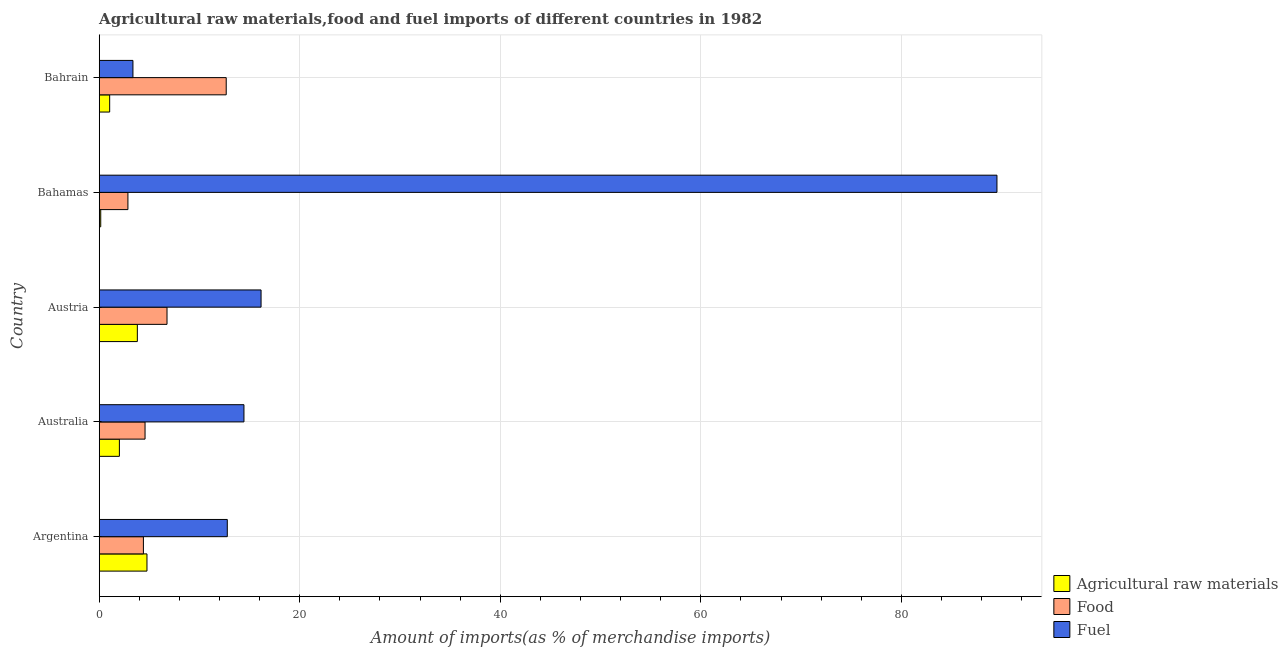How many groups of bars are there?
Ensure brevity in your answer.  5. How many bars are there on the 2nd tick from the top?
Keep it short and to the point. 3. What is the label of the 2nd group of bars from the top?
Your answer should be very brief. Bahamas. In how many cases, is the number of bars for a given country not equal to the number of legend labels?
Make the answer very short. 0. What is the percentage of fuel imports in Argentina?
Your response must be concise. 12.77. Across all countries, what is the maximum percentage of fuel imports?
Offer a terse response. 89.53. Across all countries, what is the minimum percentage of fuel imports?
Give a very brief answer. 3.36. In which country was the percentage of food imports minimum?
Offer a very short reply. Bahamas. What is the total percentage of raw materials imports in the graph?
Your answer should be compact. 11.77. What is the difference between the percentage of fuel imports in Austria and that in Bahamas?
Provide a short and direct response. -73.39. What is the difference between the percentage of raw materials imports in Australia and the percentage of fuel imports in Bahrain?
Provide a short and direct response. -1.35. What is the average percentage of food imports per country?
Offer a terse response. 6.25. What is the difference between the percentage of fuel imports and percentage of raw materials imports in Argentina?
Your answer should be compact. 8.01. What is the ratio of the percentage of food imports in Australia to that in Bahamas?
Offer a terse response. 1.6. Is the percentage of food imports in Australia less than that in Austria?
Your answer should be very brief. Yes. What is the difference between the highest and the second highest percentage of fuel imports?
Offer a very short reply. 73.39. What is the difference between the highest and the lowest percentage of fuel imports?
Your response must be concise. 86.17. In how many countries, is the percentage of food imports greater than the average percentage of food imports taken over all countries?
Give a very brief answer. 2. Is the sum of the percentage of food imports in Argentina and Austria greater than the maximum percentage of raw materials imports across all countries?
Offer a terse response. Yes. What does the 3rd bar from the top in Argentina represents?
Provide a short and direct response. Agricultural raw materials. What does the 3rd bar from the bottom in Austria represents?
Your answer should be very brief. Fuel. Where does the legend appear in the graph?
Ensure brevity in your answer.  Bottom right. What is the title of the graph?
Make the answer very short. Agricultural raw materials,food and fuel imports of different countries in 1982. What is the label or title of the X-axis?
Offer a terse response. Amount of imports(as % of merchandise imports). What is the Amount of imports(as % of merchandise imports) of Agricultural raw materials in Argentina?
Offer a terse response. 4.76. What is the Amount of imports(as % of merchandise imports) in Food in Argentina?
Keep it short and to the point. 4.41. What is the Amount of imports(as % of merchandise imports) of Fuel in Argentina?
Give a very brief answer. 12.77. What is the Amount of imports(as % of merchandise imports) of Agricultural raw materials in Australia?
Your response must be concise. 2.01. What is the Amount of imports(as % of merchandise imports) in Food in Australia?
Provide a short and direct response. 4.57. What is the Amount of imports(as % of merchandise imports) in Fuel in Australia?
Provide a short and direct response. 14.43. What is the Amount of imports(as % of merchandise imports) of Agricultural raw materials in Austria?
Offer a very short reply. 3.8. What is the Amount of imports(as % of merchandise imports) of Food in Austria?
Provide a succinct answer. 6.76. What is the Amount of imports(as % of merchandise imports) of Fuel in Austria?
Offer a very short reply. 16.14. What is the Amount of imports(as % of merchandise imports) in Agricultural raw materials in Bahamas?
Provide a succinct answer. 0.15. What is the Amount of imports(as % of merchandise imports) in Food in Bahamas?
Offer a very short reply. 2.86. What is the Amount of imports(as % of merchandise imports) in Fuel in Bahamas?
Offer a very short reply. 89.53. What is the Amount of imports(as % of merchandise imports) of Agricultural raw materials in Bahrain?
Ensure brevity in your answer.  1.04. What is the Amount of imports(as % of merchandise imports) in Food in Bahrain?
Your answer should be compact. 12.67. What is the Amount of imports(as % of merchandise imports) of Fuel in Bahrain?
Offer a very short reply. 3.36. Across all countries, what is the maximum Amount of imports(as % of merchandise imports) in Agricultural raw materials?
Ensure brevity in your answer.  4.76. Across all countries, what is the maximum Amount of imports(as % of merchandise imports) in Food?
Your answer should be very brief. 12.67. Across all countries, what is the maximum Amount of imports(as % of merchandise imports) in Fuel?
Your response must be concise. 89.53. Across all countries, what is the minimum Amount of imports(as % of merchandise imports) of Agricultural raw materials?
Ensure brevity in your answer.  0.15. Across all countries, what is the minimum Amount of imports(as % of merchandise imports) in Food?
Make the answer very short. 2.86. Across all countries, what is the minimum Amount of imports(as % of merchandise imports) of Fuel?
Ensure brevity in your answer.  3.36. What is the total Amount of imports(as % of merchandise imports) of Agricultural raw materials in the graph?
Provide a short and direct response. 11.77. What is the total Amount of imports(as % of merchandise imports) of Food in the graph?
Provide a succinct answer. 31.27. What is the total Amount of imports(as % of merchandise imports) of Fuel in the graph?
Your answer should be compact. 136.25. What is the difference between the Amount of imports(as % of merchandise imports) of Agricultural raw materials in Argentina and that in Australia?
Keep it short and to the point. 2.75. What is the difference between the Amount of imports(as % of merchandise imports) in Food in Argentina and that in Australia?
Offer a terse response. -0.16. What is the difference between the Amount of imports(as % of merchandise imports) of Fuel in Argentina and that in Australia?
Keep it short and to the point. -1.66. What is the difference between the Amount of imports(as % of merchandise imports) of Agricultural raw materials in Argentina and that in Austria?
Offer a very short reply. 0.96. What is the difference between the Amount of imports(as % of merchandise imports) in Food in Argentina and that in Austria?
Offer a very short reply. -2.35. What is the difference between the Amount of imports(as % of merchandise imports) of Fuel in Argentina and that in Austria?
Provide a succinct answer. -3.37. What is the difference between the Amount of imports(as % of merchandise imports) in Agricultural raw materials in Argentina and that in Bahamas?
Your answer should be very brief. 4.61. What is the difference between the Amount of imports(as % of merchandise imports) of Food in Argentina and that in Bahamas?
Keep it short and to the point. 1.54. What is the difference between the Amount of imports(as % of merchandise imports) of Fuel in Argentina and that in Bahamas?
Provide a succinct answer. -76.76. What is the difference between the Amount of imports(as % of merchandise imports) of Agricultural raw materials in Argentina and that in Bahrain?
Your response must be concise. 3.72. What is the difference between the Amount of imports(as % of merchandise imports) in Food in Argentina and that in Bahrain?
Keep it short and to the point. -8.26. What is the difference between the Amount of imports(as % of merchandise imports) in Fuel in Argentina and that in Bahrain?
Your answer should be very brief. 9.41. What is the difference between the Amount of imports(as % of merchandise imports) of Agricultural raw materials in Australia and that in Austria?
Make the answer very short. -1.79. What is the difference between the Amount of imports(as % of merchandise imports) of Food in Australia and that in Austria?
Offer a terse response. -2.19. What is the difference between the Amount of imports(as % of merchandise imports) in Fuel in Australia and that in Austria?
Your answer should be compact. -1.71. What is the difference between the Amount of imports(as % of merchandise imports) of Agricultural raw materials in Australia and that in Bahamas?
Make the answer very short. 1.86. What is the difference between the Amount of imports(as % of merchandise imports) of Food in Australia and that in Bahamas?
Give a very brief answer. 1.71. What is the difference between the Amount of imports(as % of merchandise imports) of Fuel in Australia and that in Bahamas?
Your answer should be very brief. -75.1. What is the difference between the Amount of imports(as % of merchandise imports) in Agricultural raw materials in Australia and that in Bahrain?
Offer a very short reply. 0.97. What is the difference between the Amount of imports(as % of merchandise imports) of Food in Australia and that in Bahrain?
Provide a succinct answer. -8.1. What is the difference between the Amount of imports(as % of merchandise imports) in Fuel in Australia and that in Bahrain?
Ensure brevity in your answer.  11.07. What is the difference between the Amount of imports(as % of merchandise imports) in Agricultural raw materials in Austria and that in Bahamas?
Keep it short and to the point. 3.65. What is the difference between the Amount of imports(as % of merchandise imports) of Food in Austria and that in Bahamas?
Your answer should be very brief. 3.9. What is the difference between the Amount of imports(as % of merchandise imports) of Fuel in Austria and that in Bahamas?
Keep it short and to the point. -73.39. What is the difference between the Amount of imports(as % of merchandise imports) in Agricultural raw materials in Austria and that in Bahrain?
Offer a very short reply. 2.76. What is the difference between the Amount of imports(as % of merchandise imports) of Food in Austria and that in Bahrain?
Keep it short and to the point. -5.91. What is the difference between the Amount of imports(as % of merchandise imports) of Fuel in Austria and that in Bahrain?
Give a very brief answer. 12.78. What is the difference between the Amount of imports(as % of merchandise imports) of Agricultural raw materials in Bahamas and that in Bahrain?
Offer a terse response. -0.89. What is the difference between the Amount of imports(as % of merchandise imports) of Food in Bahamas and that in Bahrain?
Give a very brief answer. -9.8. What is the difference between the Amount of imports(as % of merchandise imports) of Fuel in Bahamas and that in Bahrain?
Provide a succinct answer. 86.17. What is the difference between the Amount of imports(as % of merchandise imports) in Agricultural raw materials in Argentina and the Amount of imports(as % of merchandise imports) in Food in Australia?
Offer a terse response. 0.19. What is the difference between the Amount of imports(as % of merchandise imports) in Agricultural raw materials in Argentina and the Amount of imports(as % of merchandise imports) in Fuel in Australia?
Your answer should be very brief. -9.67. What is the difference between the Amount of imports(as % of merchandise imports) in Food in Argentina and the Amount of imports(as % of merchandise imports) in Fuel in Australia?
Make the answer very short. -10.03. What is the difference between the Amount of imports(as % of merchandise imports) of Agricultural raw materials in Argentina and the Amount of imports(as % of merchandise imports) of Food in Austria?
Provide a short and direct response. -2. What is the difference between the Amount of imports(as % of merchandise imports) in Agricultural raw materials in Argentina and the Amount of imports(as % of merchandise imports) in Fuel in Austria?
Offer a very short reply. -11.38. What is the difference between the Amount of imports(as % of merchandise imports) in Food in Argentina and the Amount of imports(as % of merchandise imports) in Fuel in Austria?
Your answer should be compact. -11.73. What is the difference between the Amount of imports(as % of merchandise imports) in Agricultural raw materials in Argentina and the Amount of imports(as % of merchandise imports) in Food in Bahamas?
Provide a succinct answer. 1.9. What is the difference between the Amount of imports(as % of merchandise imports) in Agricultural raw materials in Argentina and the Amount of imports(as % of merchandise imports) in Fuel in Bahamas?
Give a very brief answer. -84.77. What is the difference between the Amount of imports(as % of merchandise imports) in Food in Argentina and the Amount of imports(as % of merchandise imports) in Fuel in Bahamas?
Keep it short and to the point. -85.13. What is the difference between the Amount of imports(as % of merchandise imports) of Agricultural raw materials in Argentina and the Amount of imports(as % of merchandise imports) of Food in Bahrain?
Give a very brief answer. -7.9. What is the difference between the Amount of imports(as % of merchandise imports) of Agricultural raw materials in Argentina and the Amount of imports(as % of merchandise imports) of Fuel in Bahrain?
Make the answer very short. 1.4. What is the difference between the Amount of imports(as % of merchandise imports) in Food in Argentina and the Amount of imports(as % of merchandise imports) in Fuel in Bahrain?
Provide a succinct answer. 1.04. What is the difference between the Amount of imports(as % of merchandise imports) of Agricultural raw materials in Australia and the Amount of imports(as % of merchandise imports) of Food in Austria?
Make the answer very short. -4.75. What is the difference between the Amount of imports(as % of merchandise imports) of Agricultural raw materials in Australia and the Amount of imports(as % of merchandise imports) of Fuel in Austria?
Offer a very short reply. -14.13. What is the difference between the Amount of imports(as % of merchandise imports) in Food in Australia and the Amount of imports(as % of merchandise imports) in Fuel in Austria?
Ensure brevity in your answer.  -11.57. What is the difference between the Amount of imports(as % of merchandise imports) in Agricultural raw materials in Australia and the Amount of imports(as % of merchandise imports) in Food in Bahamas?
Make the answer very short. -0.85. What is the difference between the Amount of imports(as % of merchandise imports) in Agricultural raw materials in Australia and the Amount of imports(as % of merchandise imports) in Fuel in Bahamas?
Keep it short and to the point. -87.52. What is the difference between the Amount of imports(as % of merchandise imports) in Food in Australia and the Amount of imports(as % of merchandise imports) in Fuel in Bahamas?
Make the answer very short. -84.96. What is the difference between the Amount of imports(as % of merchandise imports) of Agricultural raw materials in Australia and the Amount of imports(as % of merchandise imports) of Food in Bahrain?
Offer a very short reply. -10.65. What is the difference between the Amount of imports(as % of merchandise imports) of Agricultural raw materials in Australia and the Amount of imports(as % of merchandise imports) of Fuel in Bahrain?
Ensure brevity in your answer.  -1.35. What is the difference between the Amount of imports(as % of merchandise imports) of Food in Australia and the Amount of imports(as % of merchandise imports) of Fuel in Bahrain?
Give a very brief answer. 1.21. What is the difference between the Amount of imports(as % of merchandise imports) in Agricultural raw materials in Austria and the Amount of imports(as % of merchandise imports) in Food in Bahamas?
Give a very brief answer. 0.94. What is the difference between the Amount of imports(as % of merchandise imports) in Agricultural raw materials in Austria and the Amount of imports(as % of merchandise imports) in Fuel in Bahamas?
Offer a terse response. -85.73. What is the difference between the Amount of imports(as % of merchandise imports) of Food in Austria and the Amount of imports(as % of merchandise imports) of Fuel in Bahamas?
Give a very brief answer. -82.77. What is the difference between the Amount of imports(as % of merchandise imports) in Agricultural raw materials in Austria and the Amount of imports(as % of merchandise imports) in Food in Bahrain?
Offer a very short reply. -8.86. What is the difference between the Amount of imports(as % of merchandise imports) in Agricultural raw materials in Austria and the Amount of imports(as % of merchandise imports) in Fuel in Bahrain?
Offer a very short reply. 0.44. What is the difference between the Amount of imports(as % of merchandise imports) in Food in Austria and the Amount of imports(as % of merchandise imports) in Fuel in Bahrain?
Make the answer very short. 3.4. What is the difference between the Amount of imports(as % of merchandise imports) of Agricultural raw materials in Bahamas and the Amount of imports(as % of merchandise imports) of Food in Bahrain?
Your answer should be compact. -12.52. What is the difference between the Amount of imports(as % of merchandise imports) in Agricultural raw materials in Bahamas and the Amount of imports(as % of merchandise imports) in Fuel in Bahrain?
Keep it short and to the point. -3.21. What is the difference between the Amount of imports(as % of merchandise imports) of Food in Bahamas and the Amount of imports(as % of merchandise imports) of Fuel in Bahrain?
Offer a terse response. -0.5. What is the average Amount of imports(as % of merchandise imports) in Agricultural raw materials per country?
Keep it short and to the point. 2.35. What is the average Amount of imports(as % of merchandise imports) in Food per country?
Ensure brevity in your answer.  6.25. What is the average Amount of imports(as % of merchandise imports) in Fuel per country?
Give a very brief answer. 27.25. What is the difference between the Amount of imports(as % of merchandise imports) in Agricultural raw materials and Amount of imports(as % of merchandise imports) in Food in Argentina?
Provide a succinct answer. 0.36. What is the difference between the Amount of imports(as % of merchandise imports) in Agricultural raw materials and Amount of imports(as % of merchandise imports) in Fuel in Argentina?
Provide a succinct answer. -8.01. What is the difference between the Amount of imports(as % of merchandise imports) in Food and Amount of imports(as % of merchandise imports) in Fuel in Argentina?
Make the answer very short. -8.37. What is the difference between the Amount of imports(as % of merchandise imports) of Agricultural raw materials and Amount of imports(as % of merchandise imports) of Food in Australia?
Offer a very short reply. -2.56. What is the difference between the Amount of imports(as % of merchandise imports) of Agricultural raw materials and Amount of imports(as % of merchandise imports) of Fuel in Australia?
Provide a short and direct response. -12.42. What is the difference between the Amount of imports(as % of merchandise imports) in Food and Amount of imports(as % of merchandise imports) in Fuel in Australia?
Your answer should be compact. -9.86. What is the difference between the Amount of imports(as % of merchandise imports) in Agricultural raw materials and Amount of imports(as % of merchandise imports) in Food in Austria?
Offer a very short reply. -2.96. What is the difference between the Amount of imports(as % of merchandise imports) in Agricultural raw materials and Amount of imports(as % of merchandise imports) in Fuel in Austria?
Offer a terse response. -12.34. What is the difference between the Amount of imports(as % of merchandise imports) of Food and Amount of imports(as % of merchandise imports) of Fuel in Austria?
Make the answer very short. -9.38. What is the difference between the Amount of imports(as % of merchandise imports) of Agricultural raw materials and Amount of imports(as % of merchandise imports) of Food in Bahamas?
Offer a terse response. -2.71. What is the difference between the Amount of imports(as % of merchandise imports) of Agricultural raw materials and Amount of imports(as % of merchandise imports) of Fuel in Bahamas?
Make the answer very short. -89.38. What is the difference between the Amount of imports(as % of merchandise imports) of Food and Amount of imports(as % of merchandise imports) of Fuel in Bahamas?
Provide a short and direct response. -86.67. What is the difference between the Amount of imports(as % of merchandise imports) in Agricultural raw materials and Amount of imports(as % of merchandise imports) in Food in Bahrain?
Make the answer very short. -11.62. What is the difference between the Amount of imports(as % of merchandise imports) in Agricultural raw materials and Amount of imports(as % of merchandise imports) in Fuel in Bahrain?
Ensure brevity in your answer.  -2.32. What is the difference between the Amount of imports(as % of merchandise imports) in Food and Amount of imports(as % of merchandise imports) in Fuel in Bahrain?
Your answer should be compact. 9.3. What is the ratio of the Amount of imports(as % of merchandise imports) in Agricultural raw materials in Argentina to that in Australia?
Provide a succinct answer. 2.37. What is the ratio of the Amount of imports(as % of merchandise imports) in Food in Argentina to that in Australia?
Your answer should be very brief. 0.96. What is the ratio of the Amount of imports(as % of merchandise imports) of Fuel in Argentina to that in Australia?
Your answer should be compact. 0.89. What is the ratio of the Amount of imports(as % of merchandise imports) in Agricultural raw materials in Argentina to that in Austria?
Ensure brevity in your answer.  1.25. What is the ratio of the Amount of imports(as % of merchandise imports) in Food in Argentina to that in Austria?
Your answer should be compact. 0.65. What is the ratio of the Amount of imports(as % of merchandise imports) in Fuel in Argentina to that in Austria?
Your answer should be very brief. 0.79. What is the ratio of the Amount of imports(as % of merchandise imports) of Agricultural raw materials in Argentina to that in Bahamas?
Give a very brief answer. 31.51. What is the ratio of the Amount of imports(as % of merchandise imports) of Food in Argentina to that in Bahamas?
Your response must be concise. 1.54. What is the ratio of the Amount of imports(as % of merchandise imports) in Fuel in Argentina to that in Bahamas?
Your answer should be very brief. 0.14. What is the ratio of the Amount of imports(as % of merchandise imports) in Agricultural raw materials in Argentina to that in Bahrain?
Provide a succinct answer. 4.57. What is the ratio of the Amount of imports(as % of merchandise imports) of Food in Argentina to that in Bahrain?
Make the answer very short. 0.35. What is the ratio of the Amount of imports(as % of merchandise imports) of Fuel in Argentina to that in Bahrain?
Provide a short and direct response. 3.8. What is the ratio of the Amount of imports(as % of merchandise imports) of Agricultural raw materials in Australia to that in Austria?
Provide a succinct answer. 0.53. What is the ratio of the Amount of imports(as % of merchandise imports) of Food in Australia to that in Austria?
Keep it short and to the point. 0.68. What is the ratio of the Amount of imports(as % of merchandise imports) of Fuel in Australia to that in Austria?
Offer a terse response. 0.89. What is the ratio of the Amount of imports(as % of merchandise imports) in Agricultural raw materials in Australia to that in Bahamas?
Your answer should be compact. 13.31. What is the ratio of the Amount of imports(as % of merchandise imports) of Food in Australia to that in Bahamas?
Offer a terse response. 1.6. What is the ratio of the Amount of imports(as % of merchandise imports) in Fuel in Australia to that in Bahamas?
Provide a succinct answer. 0.16. What is the ratio of the Amount of imports(as % of merchandise imports) of Agricultural raw materials in Australia to that in Bahrain?
Offer a very short reply. 1.93. What is the ratio of the Amount of imports(as % of merchandise imports) of Food in Australia to that in Bahrain?
Give a very brief answer. 0.36. What is the ratio of the Amount of imports(as % of merchandise imports) of Fuel in Australia to that in Bahrain?
Your answer should be compact. 4.29. What is the ratio of the Amount of imports(as % of merchandise imports) of Agricultural raw materials in Austria to that in Bahamas?
Keep it short and to the point. 25.16. What is the ratio of the Amount of imports(as % of merchandise imports) in Food in Austria to that in Bahamas?
Your response must be concise. 2.36. What is the ratio of the Amount of imports(as % of merchandise imports) in Fuel in Austria to that in Bahamas?
Offer a very short reply. 0.18. What is the ratio of the Amount of imports(as % of merchandise imports) in Agricultural raw materials in Austria to that in Bahrain?
Provide a succinct answer. 3.65. What is the ratio of the Amount of imports(as % of merchandise imports) of Food in Austria to that in Bahrain?
Offer a terse response. 0.53. What is the ratio of the Amount of imports(as % of merchandise imports) of Fuel in Austria to that in Bahrain?
Provide a short and direct response. 4.8. What is the ratio of the Amount of imports(as % of merchandise imports) in Agricultural raw materials in Bahamas to that in Bahrain?
Provide a short and direct response. 0.14. What is the ratio of the Amount of imports(as % of merchandise imports) in Food in Bahamas to that in Bahrain?
Provide a succinct answer. 0.23. What is the ratio of the Amount of imports(as % of merchandise imports) of Fuel in Bahamas to that in Bahrain?
Ensure brevity in your answer.  26.62. What is the difference between the highest and the second highest Amount of imports(as % of merchandise imports) of Agricultural raw materials?
Ensure brevity in your answer.  0.96. What is the difference between the highest and the second highest Amount of imports(as % of merchandise imports) in Food?
Give a very brief answer. 5.91. What is the difference between the highest and the second highest Amount of imports(as % of merchandise imports) in Fuel?
Make the answer very short. 73.39. What is the difference between the highest and the lowest Amount of imports(as % of merchandise imports) in Agricultural raw materials?
Your answer should be compact. 4.61. What is the difference between the highest and the lowest Amount of imports(as % of merchandise imports) in Food?
Keep it short and to the point. 9.8. What is the difference between the highest and the lowest Amount of imports(as % of merchandise imports) of Fuel?
Your answer should be compact. 86.17. 